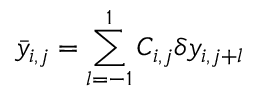Convert formula to latex. <formula><loc_0><loc_0><loc_500><loc_500>\bar { y } _ { i , j } = \sum _ { l = - 1 } ^ { 1 } C _ { i , j } \delta y _ { i , j + l }</formula> 